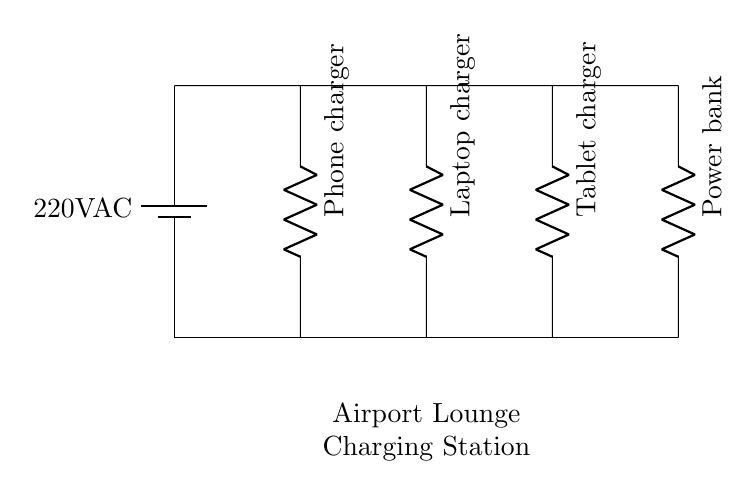What is the voltage of this circuit? The voltage of the circuit is specified as 220V AC, which is shown next to the battery component in the circuit diagram.
Answer: 220V AC What devices are connected in parallel in this circuit? The devices connected in parallel are a phone charger, laptop charger, tablet charger, and a power bank, each represented by a resistor symbol in the diagram.
Answer: Phone charger, laptop charger, tablet charger, power bank How many devices are charging simultaneously? There are four devices connected, which allows them to charge simultaneously since they are all in a parallel configuration.
Answer: Four What is the configuration type of this circuit? The configuration type of this circuit is parallel, indicated by the branches extending from the main power line to each device without interfering with one another's operation.
Answer: Parallel Which component serves as the power source? The power source is the battery labeled with 220V AC, providing the necessary voltage to all connected devices.
Answer: Battery 